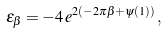<formula> <loc_0><loc_0><loc_500><loc_500>\epsilon _ { \beta } = - 4 \, e ^ { 2 ( - 2 \pi \beta + \psi ( 1 ) ) } \, ,</formula> 